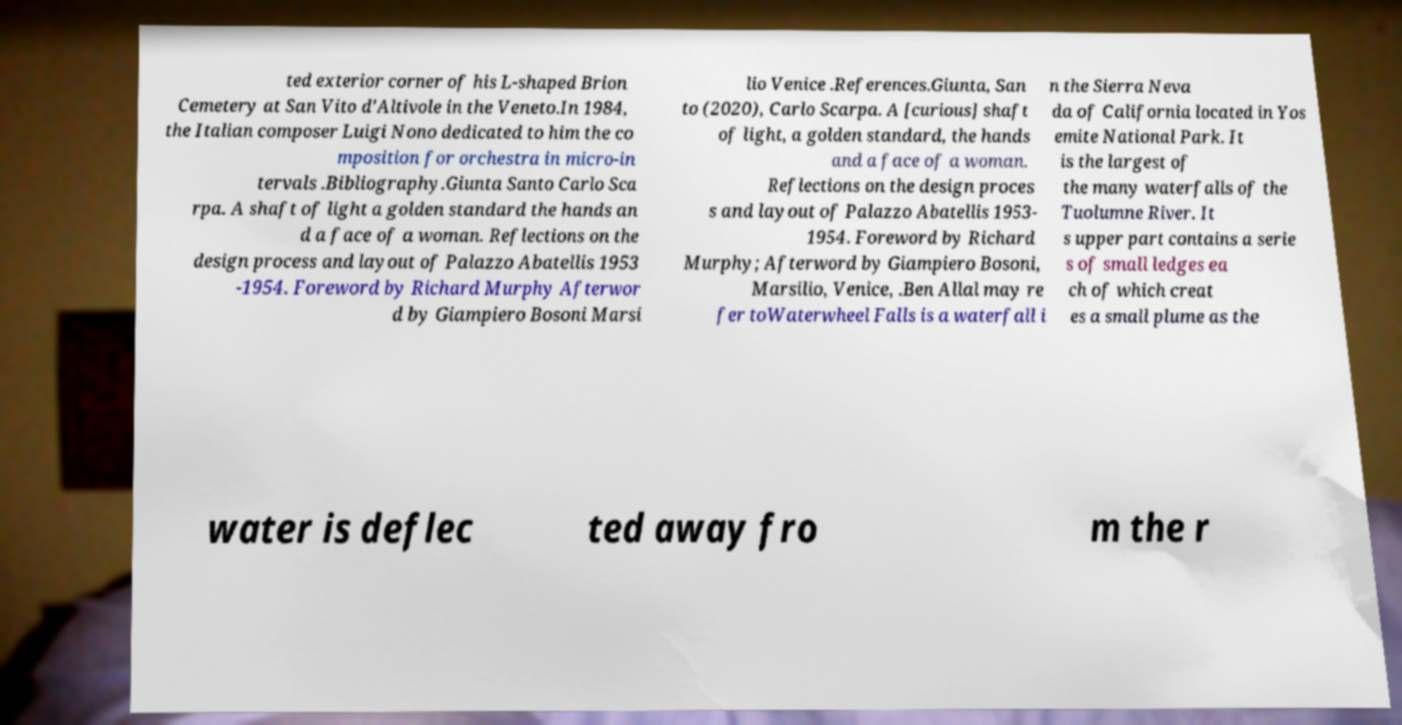Can you accurately transcribe the text from the provided image for me? ted exterior corner of his L-shaped Brion Cemetery at San Vito d'Altivole in the Veneto.In 1984, the Italian composer Luigi Nono dedicated to him the co mposition for orchestra in micro-in tervals .Bibliography.Giunta Santo Carlo Sca rpa. A shaft of light a golden standard the hands an d a face of a woman. Reflections on the design process and layout of Palazzo Abatellis 1953 -1954. Foreword by Richard Murphy Afterwor d by Giampiero Bosoni Marsi lio Venice .References.Giunta, San to (2020), Carlo Scarpa. A [curious] shaft of light, a golden standard, the hands and a face of a woman. Reflections on the design proces s and layout of Palazzo Abatellis 1953- 1954. Foreword by Richard Murphy; Afterword by Giampiero Bosoni, Marsilio, Venice, .Ben Allal may re fer toWaterwheel Falls is a waterfall i n the Sierra Neva da of California located in Yos emite National Park. It is the largest of the many waterfalls of the Tuolumne River. It s upper part contains a serie s of small ledges ea ch of which creat es a small plume as the water is deflec ted away fro m the r 